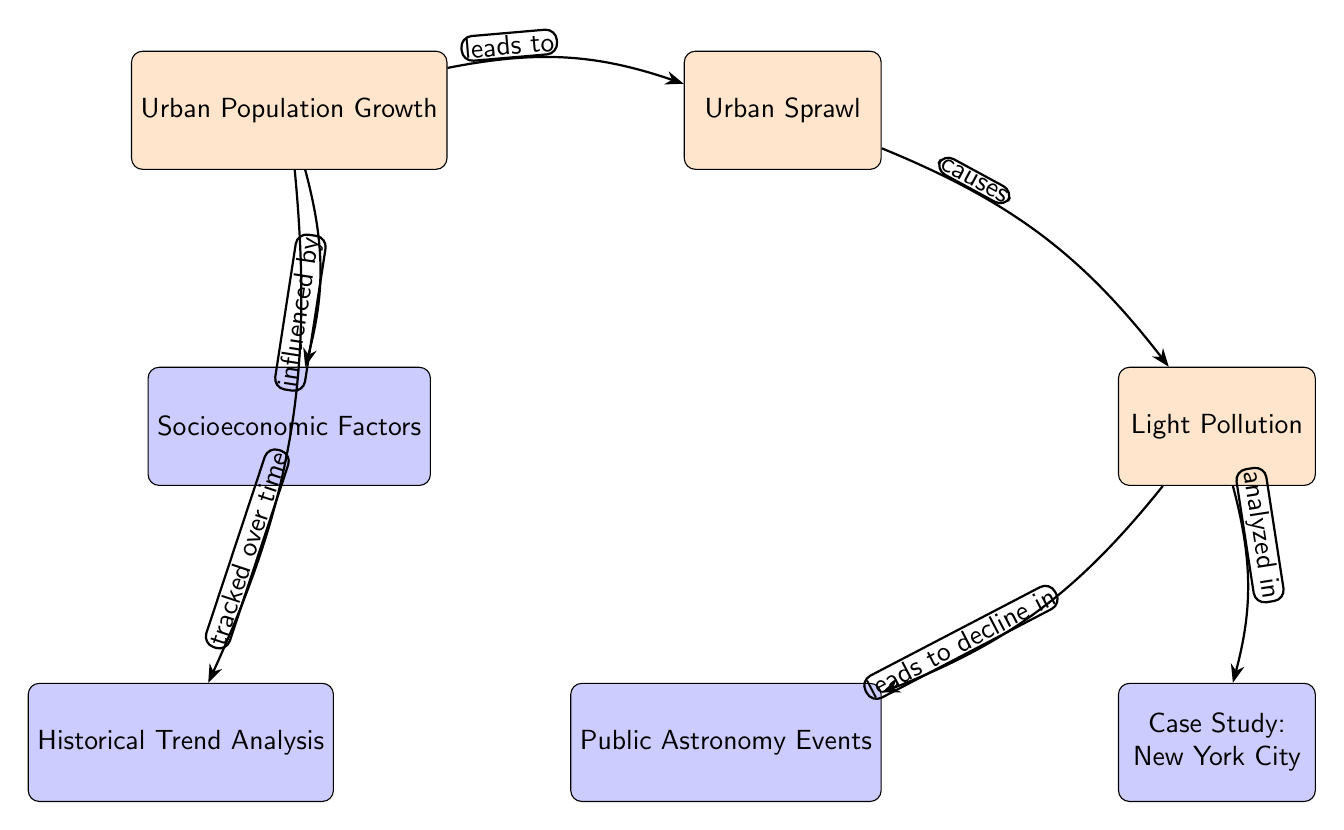What is the main cause listed in the diagram for light pollution? The diagram shows a direct link from "Urban Sprawl" to "Light Pollution" marked by "causes," indicating that urban sprawl is identified as the main cause for light pollution.
Answer: Urban Sprawl How many main nodes are present in the diagram? Counting the nodes classified as "main node," we find three: "Urban Population Growth," "Urban Sprawl," and "Light Pollution," resulting in a total of three main nodes.
Answer: Three What node is directly influenced by urban population growth? The diagram shows a direct connection from "Urban Population Growth" to "Urban Sprawl," indicating that the urban sprawl is influenced by urban population growth.
Answer: Urban Sprawl Which node refers to events that have declined due to light pollution? The diagram explicitly states that "Light Pollution" leads to a decline in "Public Astronomy Events," indicating this is the node that refers to those events.
Answer: Public Astronomy Events What type of analysis is connected to urban population growth? The diagram connects "Urban Population Growth" to "Historical Trend Analysis" marked by the phrase "tracked over time," linking the growth to the analysis type.
Answer: Historical Trend Analysis How many edges are illustrated in this diagram? The diagram has five edges connecting different nodes, which can be counted by identifying the links between the nodes.
Answer: Five Which node is analyzed in relation to light pollution? The diagram shows a connection from "Light Pollution" to "Case Study: New York City," indicating that this node is analyzed concerning light pollution.
Answer: Case Study: New York City What socioeconomic factor is mentioned that influences urban population growth? The diagram indicates a direct relationship where "Urban Population Growth" is influenced by "Socioeconomic Factors," which denotes the influencing factors.
Answer: Socioeconomic Factors Which node is affected by urban sprawl through light pollution? The diagram illustrates that "Public Astronomy Events" is the node that declines due to "Light Pollution," which is caused by "Urban Sprawl."
Answer: Public Astronomy Events 